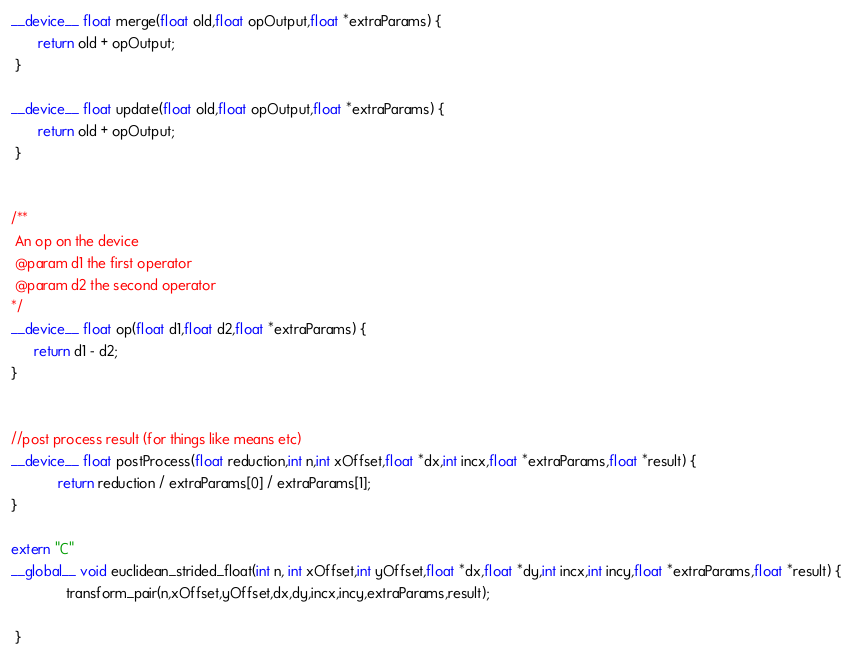<code> <loc_0><loc_0><loc_500><loc_500><_Cuda_>
__device__ float merge(float old,float opOutput,float *extraParams) {
       return old + opOutput;
 }

__device__ float update(float old,float opOutput,float *extraParams) {
       return old + opOutput;
 }


/**
 An op on the device
 @param d1 the first operator
 @param d2 the second operator
*/
__device__ float op(float d1,float d2,float *extraParams) {
      return d1 - d2;
}


//post process result (for things like means etc)
__device__ float postProcess(float reduction,int n,int xOffset,float *dx,int incx,float *extraParams,float *result) {
            return reduction / extraParams[0] / extraParams[1];
}

extern "C"
__global__ void euclidean_strided_float(int n, int xOffset,int yOffset,float *dx,float *dy,int incx,int incy,float *extraParams,float *result) {
              transform_pair(n,xOffset,yOffset,dx,dy,incx,incy,extraParams,result);

 }


</code> 